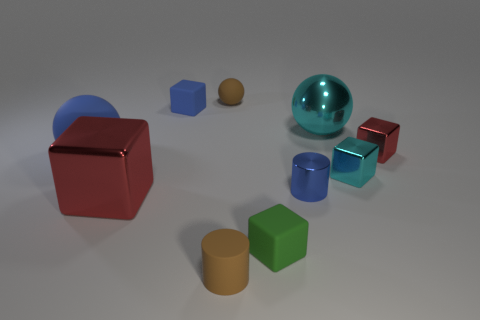Subtract all green blocks. How many blocks are left? 4 Subtract all large metal blocks. How many blocks are left? 4 Subtract all purple blocks. Subtract all brown balls. How many blocks are left? 5 Subtract all cylinders. How many objects are left? 8 Add 8 small gray cubes. How many small gray cubes exist? 8 Subtract 1 green cubes. How many objects are left? 9 Subtract all big cyan shiny balls. Subtract all tiny metal cubes. How many objects are left? 7 Add 6 tiny blue rubber objects. How many tiny blue rubber objects are left? 7 